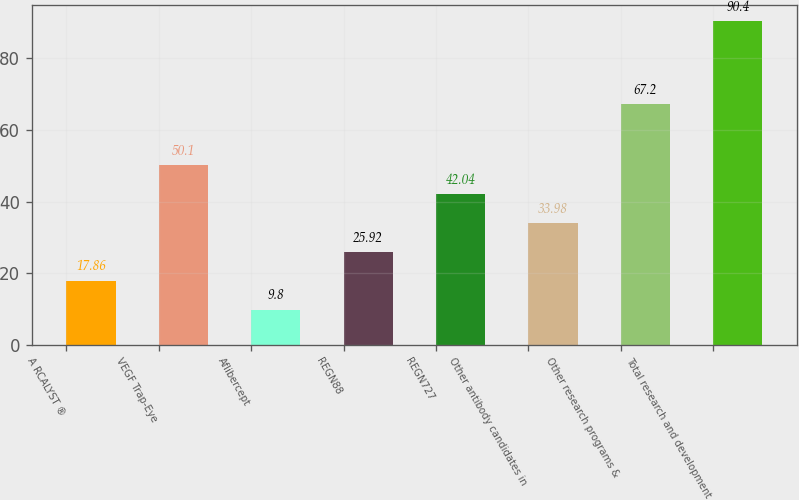Convert chart. <chart><loc_0><loc_0><loc_500><loc_500><bar_chart><fcel>A RCALYST ®<fcel>VEGF Trap-Eye<fcel>Aflibercept<fcel>REGN88<fcel>REGN727<fcel>Other antibody candidates in<fcel>Other research programs &<fcel>Total research and development<nl><fcel>17.86<fcel>50.1<fcel>9.8<fcel>25.92<fcel>42.04<fcel>33.98<fcel>67.2<fcel>90.4<nl></chart> 